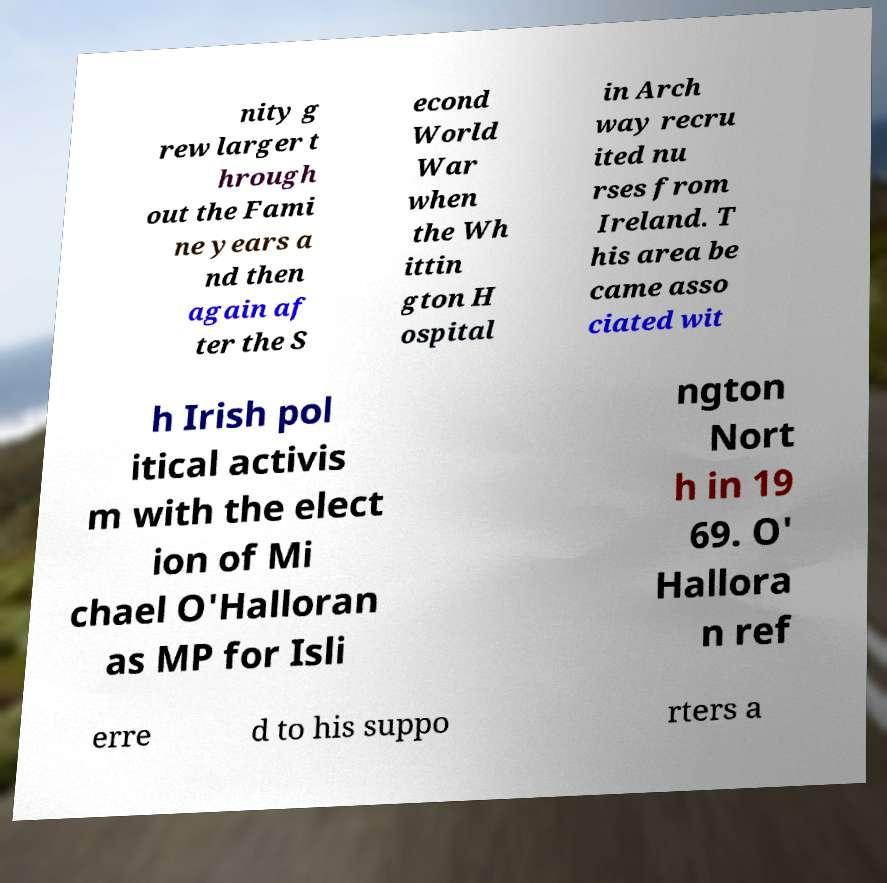Please identify and transcribe the text found in this image. nity g rew larger t hrough out the Fami ne years a nd then again af ter the S econd World War when the Wh ittin gton H ospital in Arch way recru ited nu rses from Ireland. T his area be came asso ciated wit h Irish pol itical activis m with the elect ion of Mi chael O'Halloran as MP for Isli ngton Nort h in 19 69. O' Hallora n ref erre d to his suppo rters a 